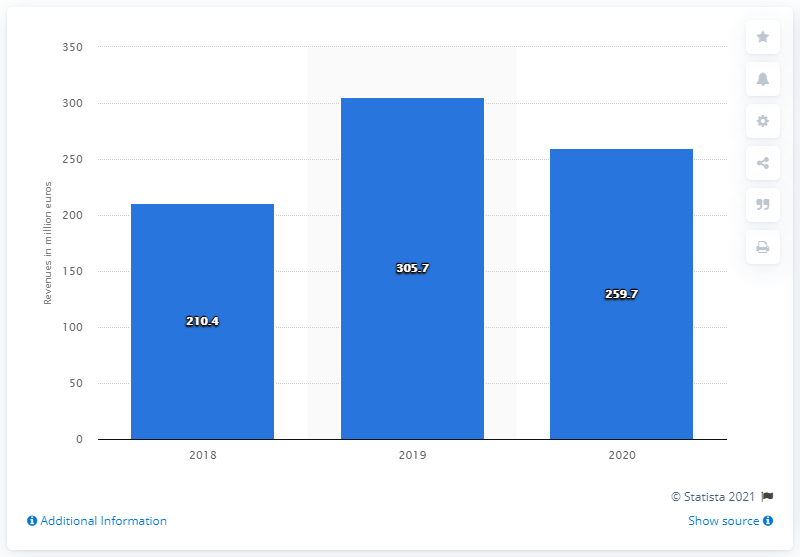Give some essential details in this illustration. The consolidated revenues of the Italian fashion company BasicNet Group in 2020 were 259.7 million euros. 